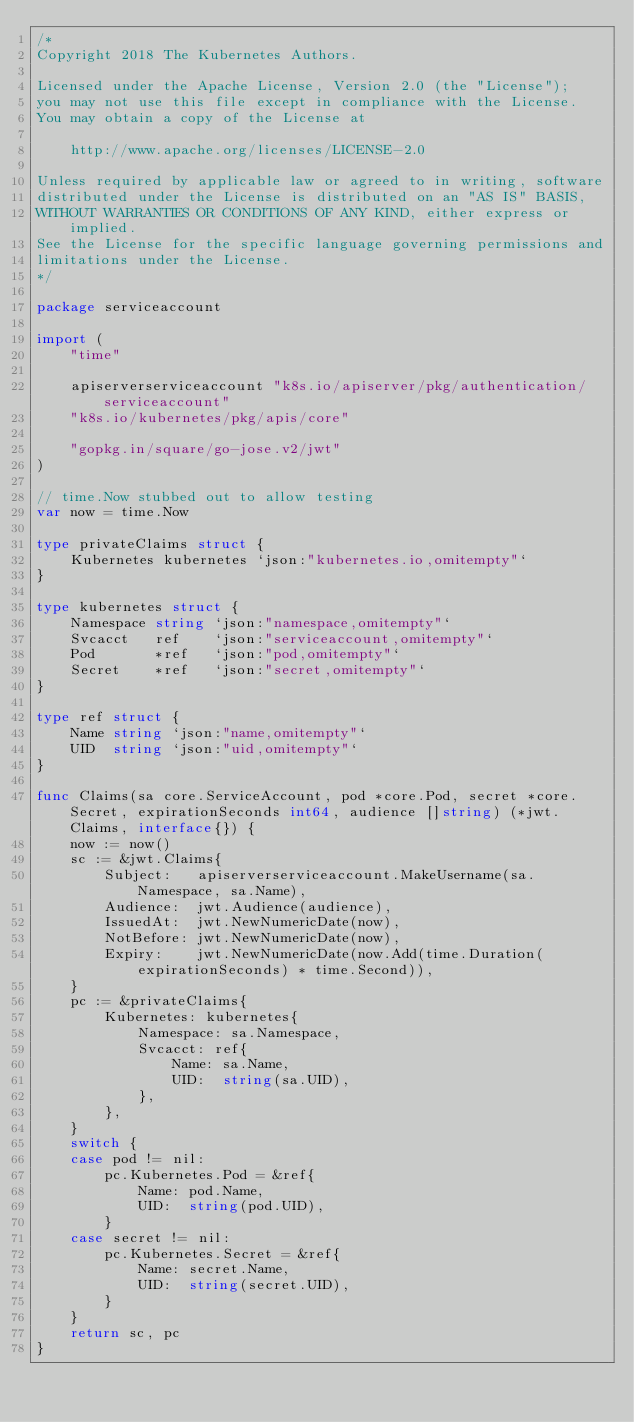<code> <loc_0><loc_0><loc_500><loc_500><_Go_>/*
Copyright 2018 The Kubernetes Authors.

Licensed under the Apache License, Version 2.0 (the "License");
you may not use this file except in compliance with the License.
You may obtain a copy of the License at

    http://www.apache.org/licenses/LICENSE-2.0

Unless required by applicable law or agreed to in writing, software
distributed under the License is distributed on an "AS IS" BASIS,
WITHOUT WARRANTIES OR CONDITIONS OF ANY KIND, either express or implied.
See the License for the specific language governing permissions and
limitations under the License.
*/

package serviceaccount

import (
	"time"

	apiserverserviceaccount "k8s.io/apiserver/pkg/authentication/serviceaccount"
	"k8s.io/kubernetes/pkg/apis/core"

	"gopkg.in/square/go-jose.v2/jwt"
)

// time.Now stubbed out to allow testing
var now = time.Now

type privateClaims struct {
	Kubernetes kubernetes `json:"kubernetes.io,omitempty"`
}

type kubernetes struct {
	Namespace string `json:"namespace,omitempty"`
	Svcacct   ref    `json:"serviceaccount,omitempty"`
	Pod       *ref   `json:"pod,omitempty"`
	Secret    *ref   `json:"secret,omitempty"`
}

type ref struct {
	Name string `json:"name,omitempty"`
	UID  string `json:"uid,omitempty"`
}

func Claims(sa core.ServiceAccount, pod *core.Pod, secret *core.Secret, expirationSeconds int64, audience []string) (*jwt.Claims, interface{}) {
	now := now()
	sc := &jwt.Claims{
		Subject:   apiserverserviceaccount.MakeUsername(sa.Namespace, sa.Name),
		Audience:  jwt.Audience(audience),
		IssuedAt:  jwt.NewNumericDate(now),
		NotBefore: jwt.NewNumericDate(now),
		Expiry:    jwt.NewNumericDate(now.Add(time.Duration(expirationSeconds) * time.Second)),
	}
	pc := &privateClaims{
		Kubernetes: kubernetes{
			Namespace: sa.Namespace,
			Svcacct: ref{
				Name: sa.Name,
				UID:  string(sa.UID),
			},
		},
	}
	switch {
	case pod != nil:
		pc.Kubernetes.Pod = &ref{
			Name: pod.Name,
			UID:  string(pod.UID),
		}
	case secret != nil:
		pc.Kubernetes.Secret = &ref{
			Name: secret.Name,
			UID:  string(secret.UID),
		}
	}
	return sc, pc
}
</code> 